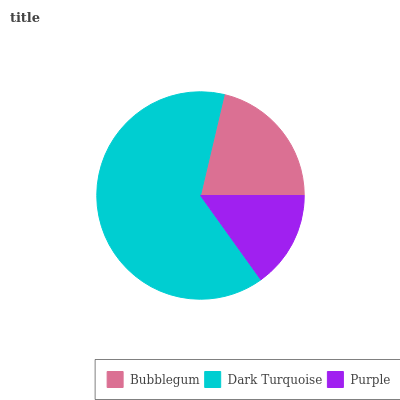Is Purple the minimum?
Answer yes or no. Yes. Is Dark Turquoise the maximum?
Answer yes or no. Yes. Is Dark Turquoise the minimum?
Answer yes or no. No. Is Purple the maximum?
Answer yes or no. No. Is Dark Turquoise greater than Purple?
Answer yes or no. Yes. Is Purple less than Dark Turquoise?
Answer yes or no. Yes. Is Purple greater than Dark Turquoise?
Answer yes or no. No. Is Dark Turquoise less than Purple?
Answer yes or no. No. Is Bubblegum the high median?
Answer yes or no. Yes. Is Bubblegum the low median?
Answer yes or no. Yes. Is Dark Turquoise the high median?
Answer yes or no. No. Is Purple the low median?
Answer yes or no. No. 